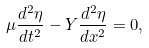<formula> <loc_0><loc_0><loc_500><loc_500>\mu \frac { d ^ { 2 } \eta } { d t ^ { 2 } } - Y \frac { d ^ { 2 } \eta } { d x ^ { 2 } } = 0 ,</formula> 